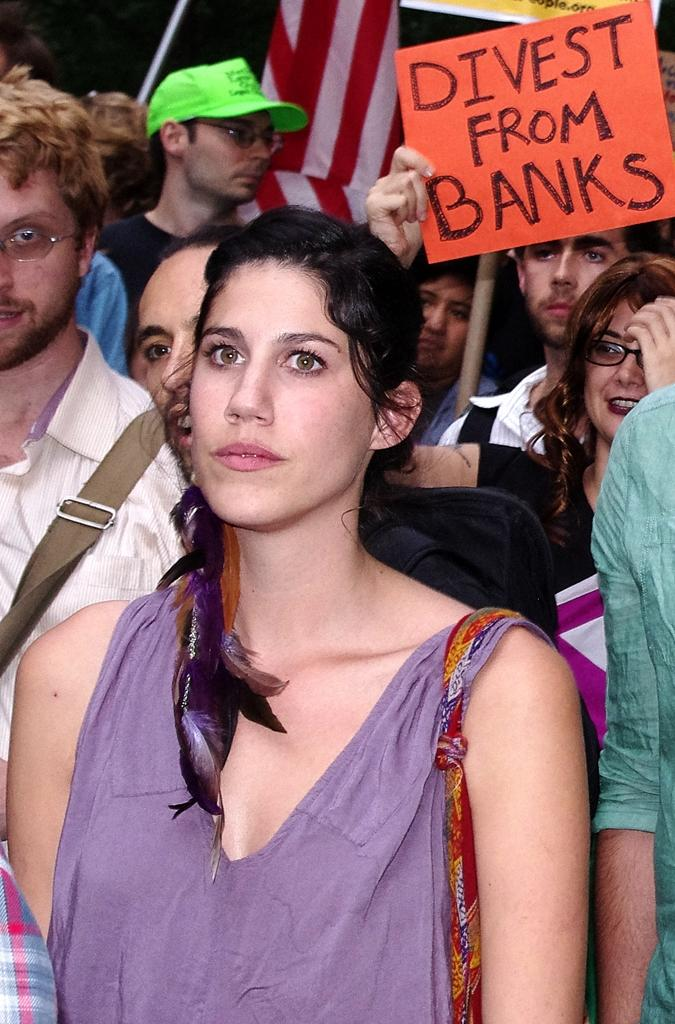How many people are in the image? There is a group of people in the image. What is one person holding in the image? One person is holding a paper with text on it. What can be seen behind the people in the image? There is a cloth visible behind the people. What type of dinner is being served in the image? There is no dinner present in the image. Can you tell me where the church is located in the image? There is no church present in the image. 